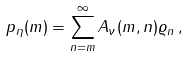Convert formula to latex. <formula><loc_0><loc_0><loc_500><loc_500>p _ { \eta } ( m ) = \sum ^ { \infty } _ { n = m } A _ { \nu } ( m , n ) \varrho _ { n } \, ,</formula> 